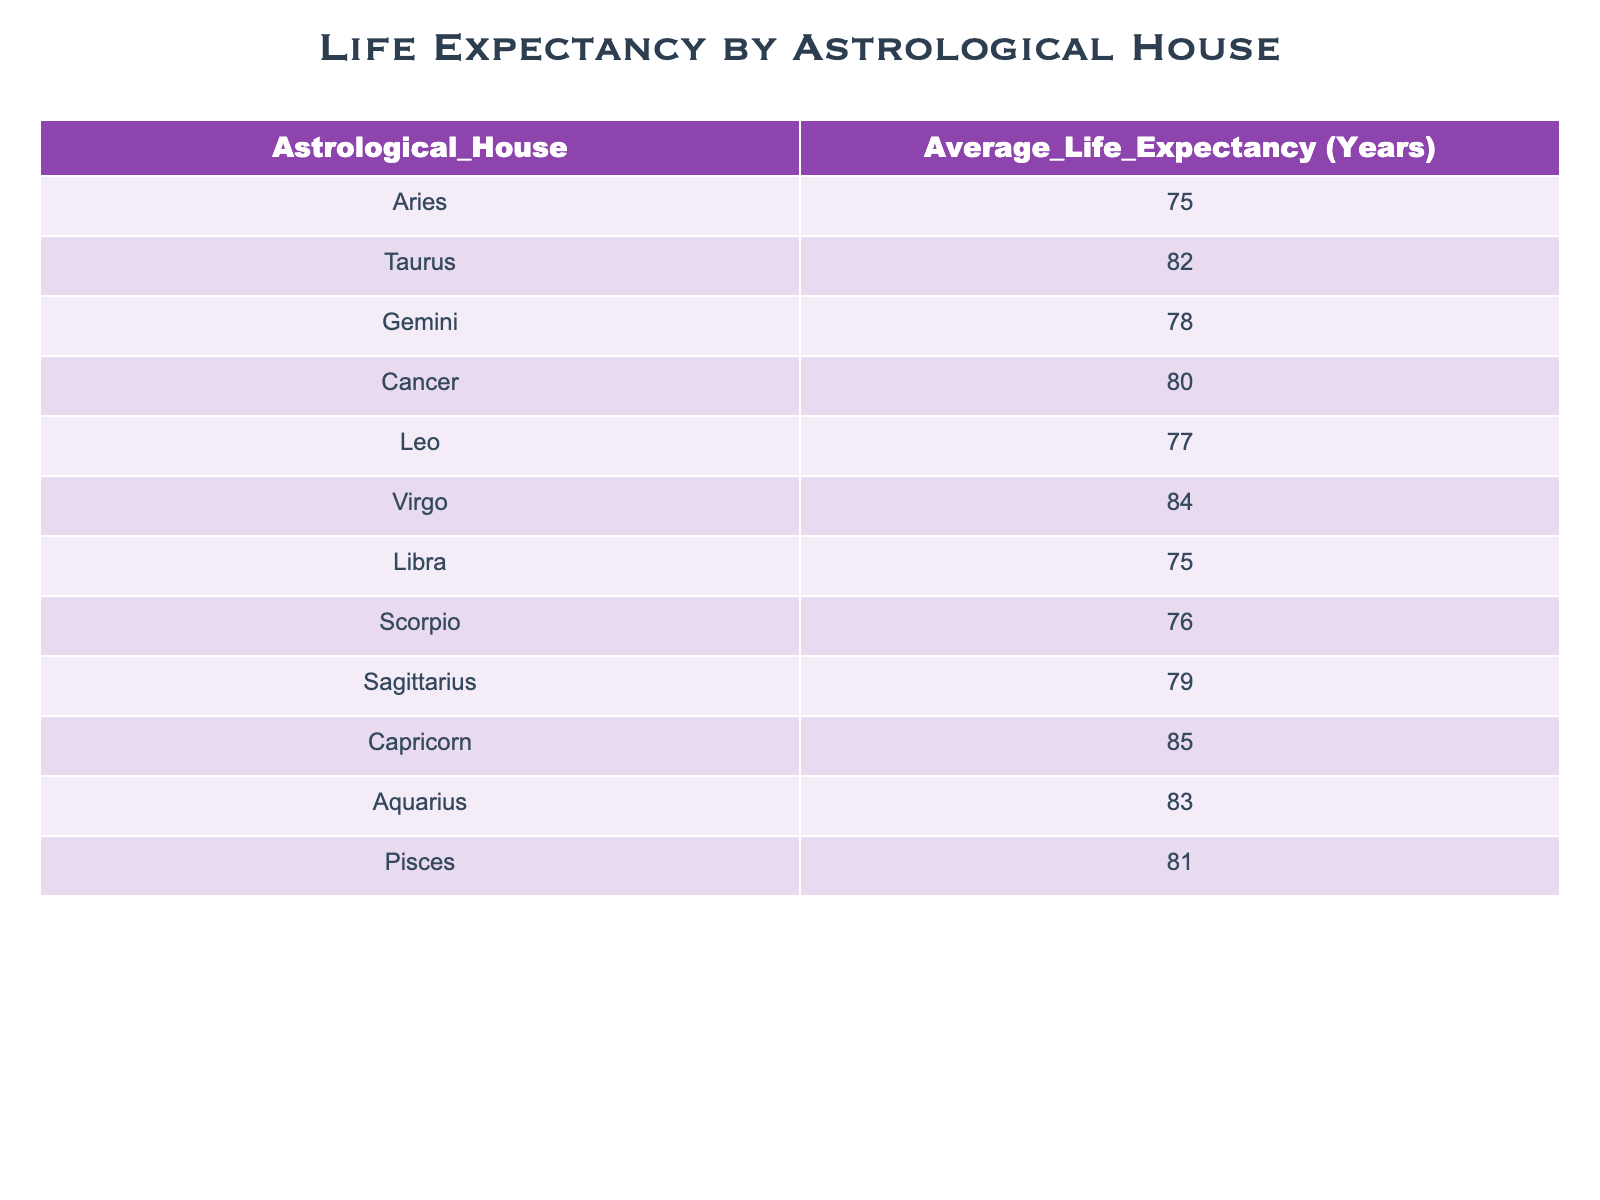What is the average life expectancy for individuals born under Gemini? According to the table, the average life expectancy for individuals born under Gemini is 78 years.
Answer: 78 Which astrological house has the highest life expectancy? From the data, Capricorn has the highest life expectancy at 85 years, which is greater than any other house listed.
Answer: Capricorn Is the average life expectancy for individuals born under Cancer greater than that of those born under Leo? Cancer's life expectancy is 80 years, while Leo's is 77 years. Since 80 is greater than 77, the statement is true.
Answer: Yes What is the difference in life expectancy between Taurus and Scorpio? Taurus has an average life expectancy of 82 years while Scorpio has 76 years. The difference is calculated as 82 - 76 = 6 years.
Answer: 6 Which group of astrological houses has a life expectancy below 80 years? The houses with a life expectancy below 80 years are Aries (75), Libra (75), Scorpio (76), and Leo (77). There are four houses in this category.
Answer: Aries, Libra, Scorpio, Leo If you calculate the average life expectancy of Virgo and Aquarius, what do you get? Virgo has a life expectancy of 84 years, and Aquarius has 83 years. Adding these gives 84 + 83 = 167. Dividing by 2 for the average gives 167 / 2 = 83.5 years.
Answer: 83.5 Do individuals born under Pisces have a higher life expectancy than those born under Sagittarius? Pisces has an average life expectancy of 81 years while Sagittarius has 79 years. Since 81 is greater than 79, the answer is true.
Answer: Yes What is the life expectancy of the astrological house with the second lowest average? The second lowest life expectancy in the table is for Scorpio at 76 years. Aries and Libra both have lower values.
Answer: 76 What is the sum of the life expectancies for Libra, Scorpio, and Sagittarius? From the table, Libra's life expectancy is 75 years, Scorpio's is 76 years, and Sagittarius's is 79 years. Adding these gives 75 + 76 + 79 = 230 years.
Answer: 230 